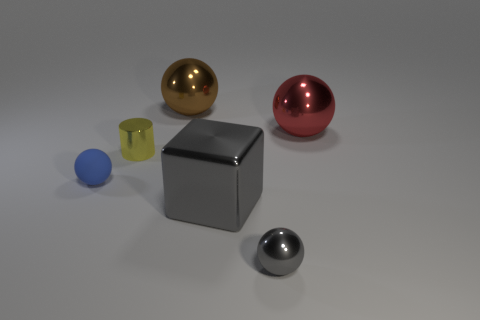How many other things are there of the same color as the cylinder?
Ensure brevity in your answer.  0. How many brown objects are large shiny cylinders or big shiny balls?
Give a very brief answer. 1. There is a tiny ball that is behind the large gray object; what is its material?
Your answer should be compact. Rubber. Is the material of the large ball to the right of the tiny metal ball the same as the blue thing?
Keep it short and to the point. No. What shape is the yellow metallic thing?
Ensure brevity in your answer.  Cylinder. There is a gray thing that is in front of the large metal object in front of the tiny cylinder; what number of balls are to the left of it?
Your answer should be compact. 2. What number of other objects are there of the same material as the big red sphere?
Provide a succinct answer. 4. There is a blue object that is the same size as the yellow metallic thing; what is its material?
Ensure brevity in your answer.  Rubber. Does the tiny metallic object to the right of the small yellow shiny object have the same color as the large thing that is in front of the yellow thing?
Offer a very short reply. Yes. Are there any gray metallic things of the same shape as the blue object?
Provide a short and direct response. Yes. 